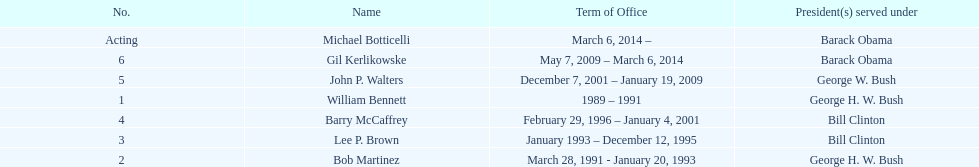Who serves inder barack obama? Gil Kerlikowske. 